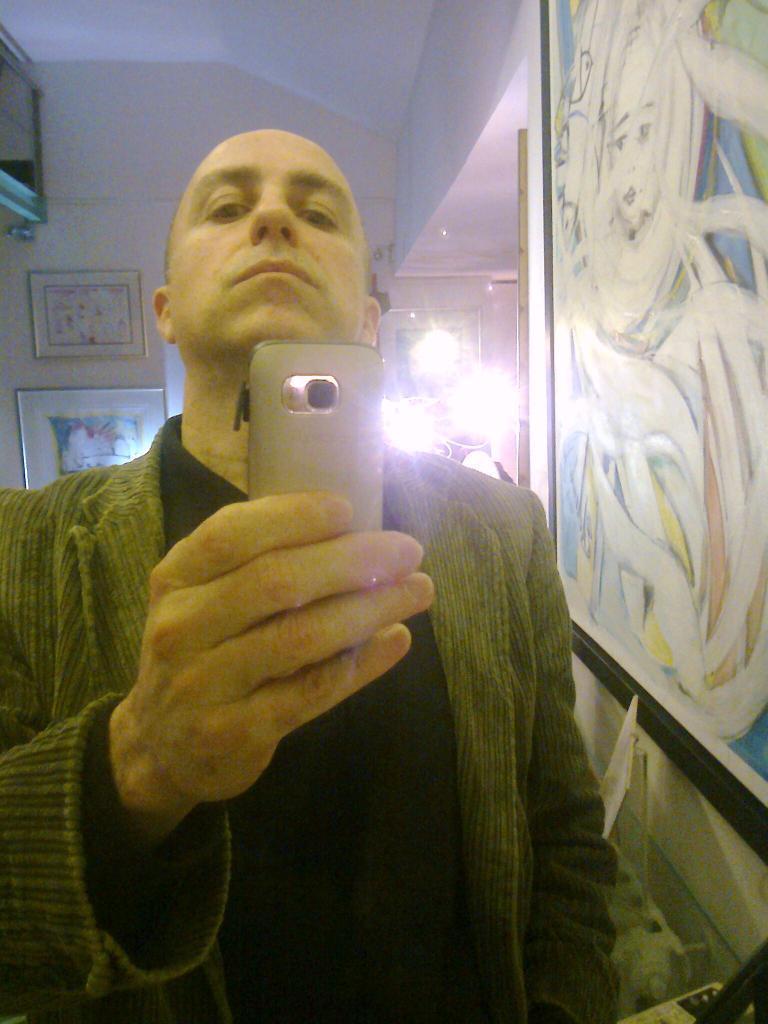How would you summarize this image in a sentence or two? This picture shows the inner view of a building. There are some frames are hanging on the wall, one cupboard, some lights and some objects are on the surface. One person is standing and holding a mobile phone. 